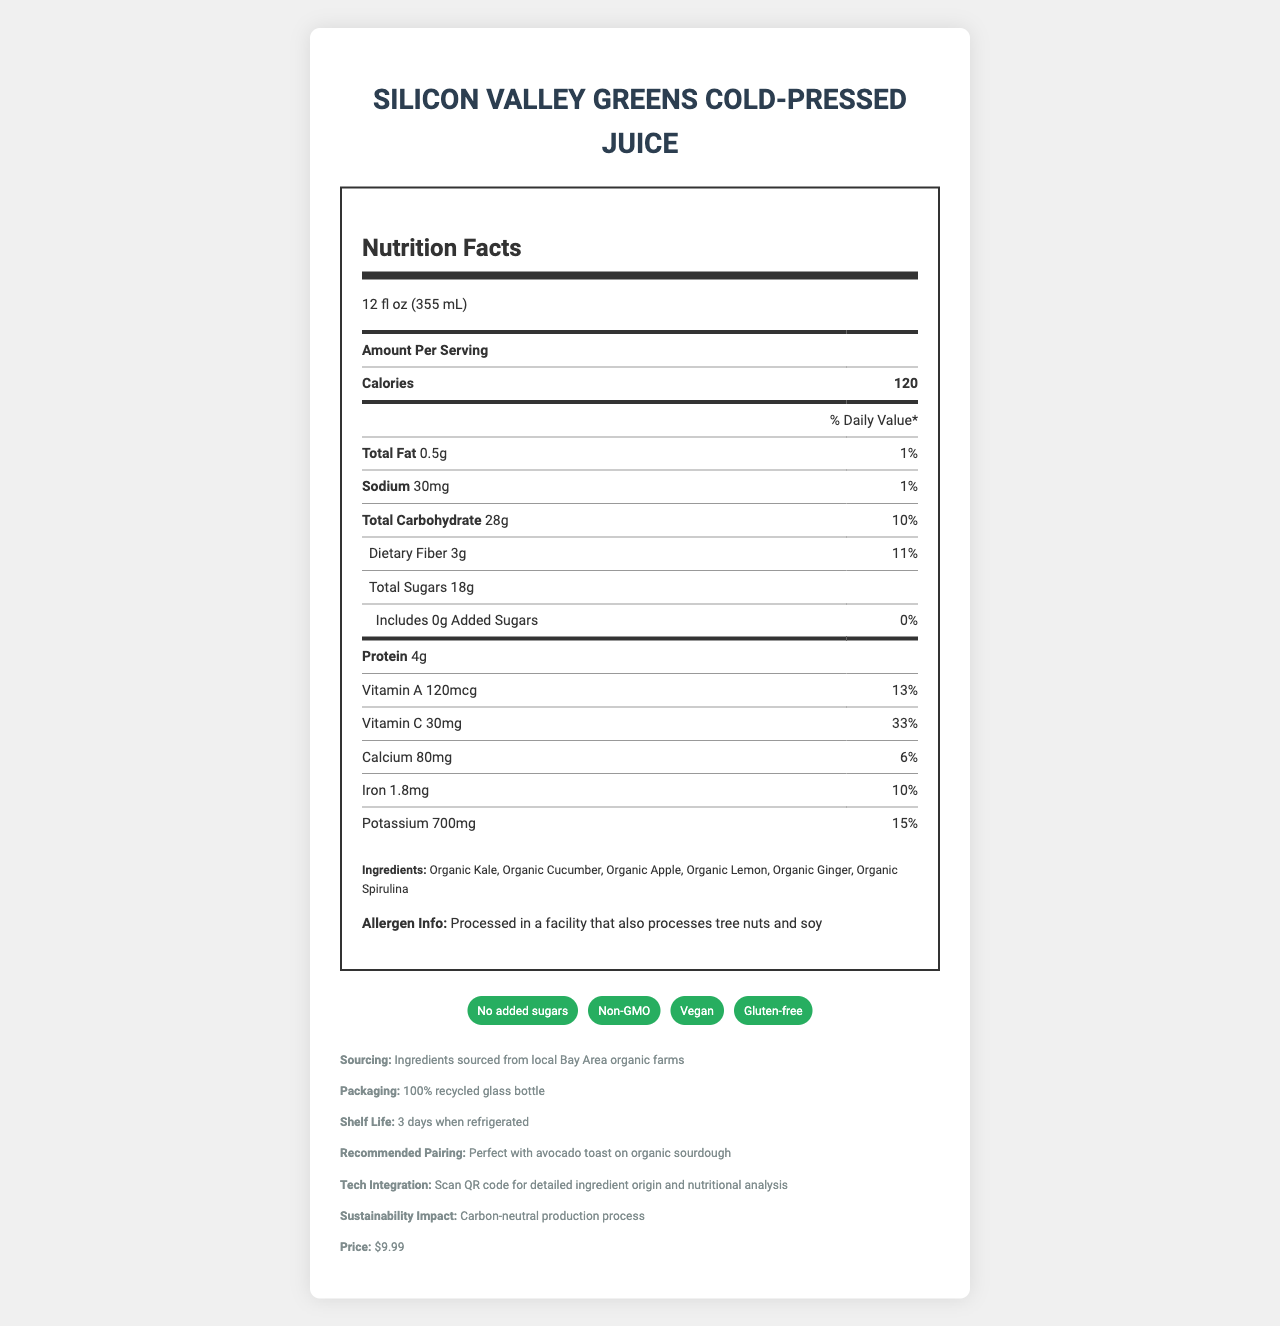what is the serving size of the Silicon Valley Greens Cold-Pressed Juice? The serving size is clearly stated at the beginning of the nutrition facts section on the document.
Answer: 12 fl oz (355 mL) how many calories are there per serving? The document shows the calorie count per serving right after the phrase "Amount Per Serving."
Answer: 120 what percentage of the daily value of dietary fiber does one serving contain? The daily value percentage for dietary fiber is listed in the section detailing the nutritional values.
Answer: 11% which ingredient is NOT included in the Silicon Valley Greens Cold-Pressed Juice?
A. Organic Kale
B. Organic Spinach
C. Organic Lemon
D. Organic Apple Organic Spinach is not listed among the ingredients; the other options are included.
Answer: B how many grams of protein are in one serving? The amount of protein per serving is listed under the nutrition facts section.
Answer: 4g is the juice a good source of Vitamin C? The nutritional label indicates that the juice provides 33% of the daily value for Vitamin C, which can be considered a good source.
Answer: Yes what is the price of this green juice? The price is mentioned in the additional information section of the document.
Answer: $9.99 how many milligrams of potassium does the juice provide per serving? The milligram content of potassium is specified in the nutrition facts table.
Answer: 700mg which of the following health claims is associated with the juice?
I. Non-GMO
II. Vegan
III. Sugar-Free
IV. Gluten-free
Options:
A. I, II, and III
B. I, II, and IV
C. II, III, and IV
D. I, III, and IV The health claims listed in the document include Non-GMO, Vegan, and Gluten-free. Sugar-Free is not mentioned (the juice is described as having no added sugars, but not completely sugar-free).
Answer: B does the juice contain any added sugars? The section detailing sugars explicitly states that it contains 0g of added sugars.
Answer: No summarize the main aspects of the Silicon Valley Greens Cold-Pressed Juice. The summary covers the Product Name, Serving Size, Nutritional Content, Ingredients, Health Claims, Sourcing and Packaging Information, and Price.
Answer: The Silicon Valley Greens Cold-Pressed Juice is a 12 fl oz (355 mL) serving of locally-sourced, organic ingredients like kale, cucumber, apple, lemon, ginger, and spirulina. It has 120 calories per serving and provides essential nutrients such as 4g of protein, 3g of fiber, and significant daily values of Vitamin A, Vitamin C, and potassium. The juice boasts health claims including non-GMO, vegan, and gluten-free, with no added sugars. The packaging is eco-friendly, and its ingredients are sourced from local Bay Area farms. The juice costs $9.99. who is the primary supplier of the ingredients? The document states that the ingredients are sourced from local Bay Area organic farms, but it does not specify a particular primary supplier.
Answer: Cannot be determined 